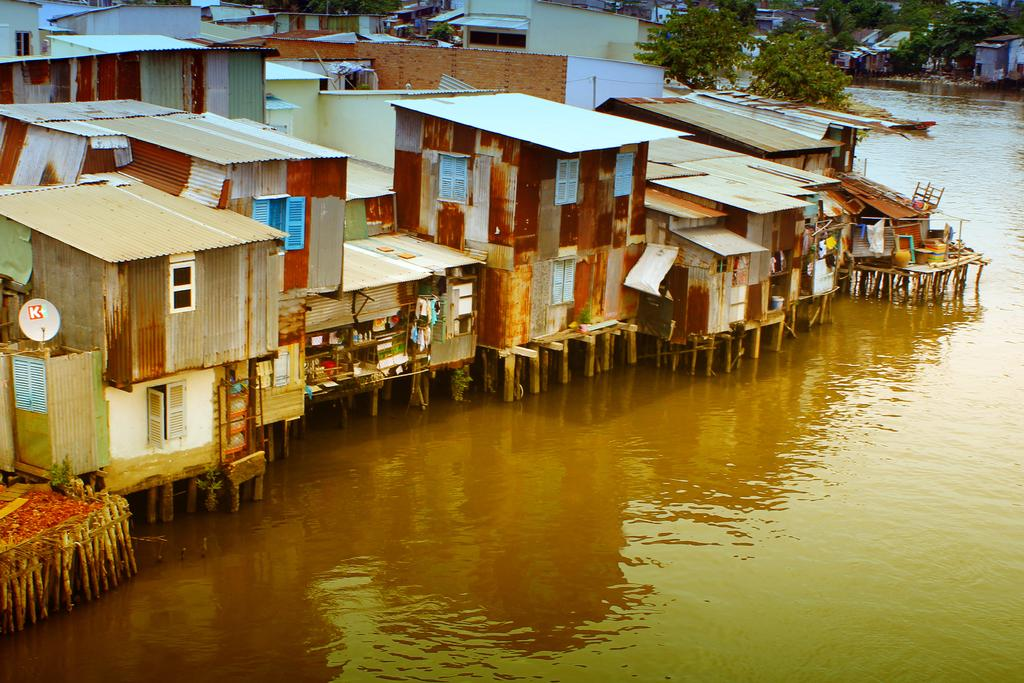What can be seen on the right side of the image? There is water visible on the right side of the image. What is visible in the background of the image? There are buildings and trees in the background of the image. What type of gate can be seen in the image? There is no gate present in the image. What position does the body of water hold in the image? The body of water is located on the right side of the image, but it does not hold a specific position or pose. 